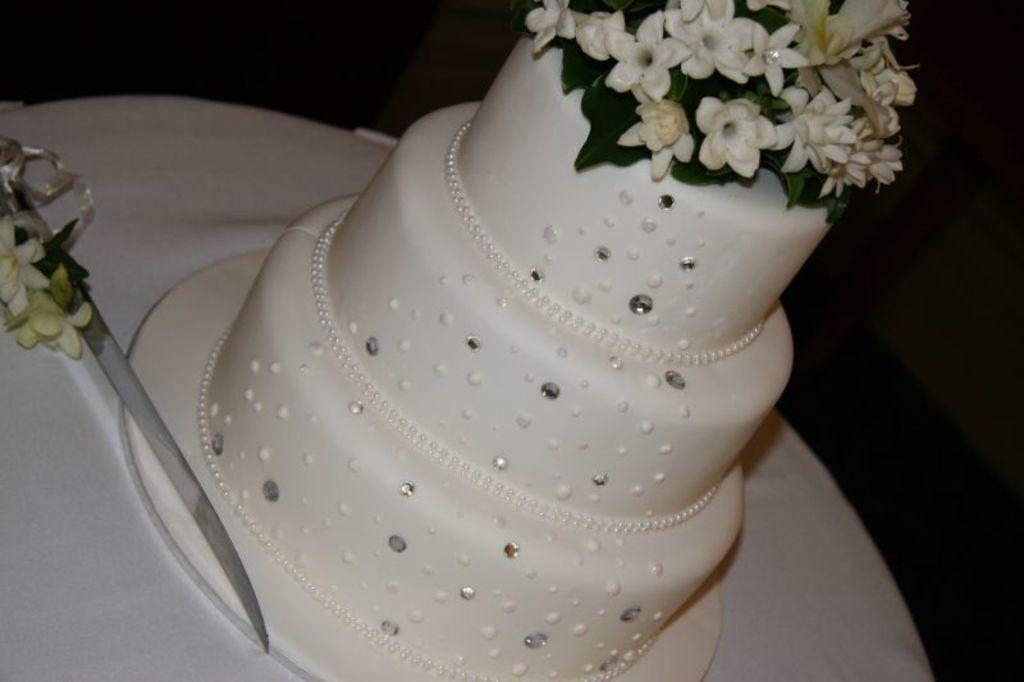What type of dessert is in the image? There is a three-tier cake in the image. Where is the cake located? The cake is placed on a table. What object is beside the cake? There is a knife beside the cake. What type of lead can be seen in the image? There is no lead present in the image. What type of play is happening in the image? There is no play or any indication of a play in the image; it features a cake on a table with a knife beside it. 